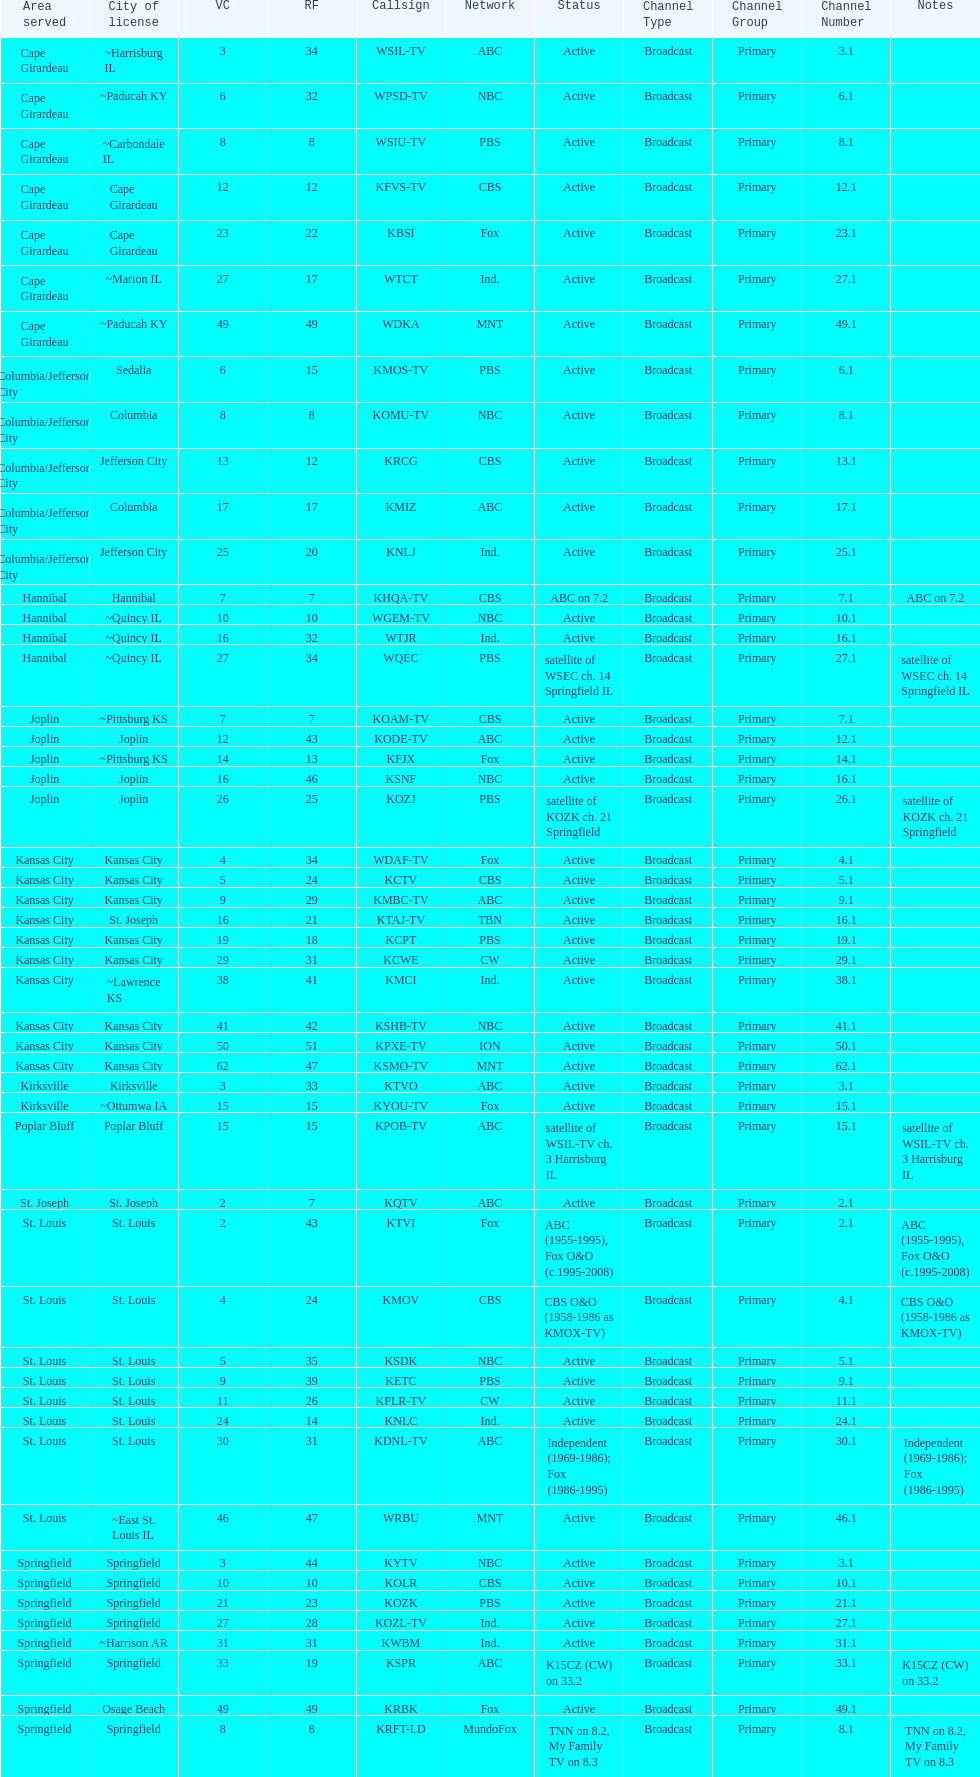Which station is licensed in the same city as koam-tv? KFJX. 